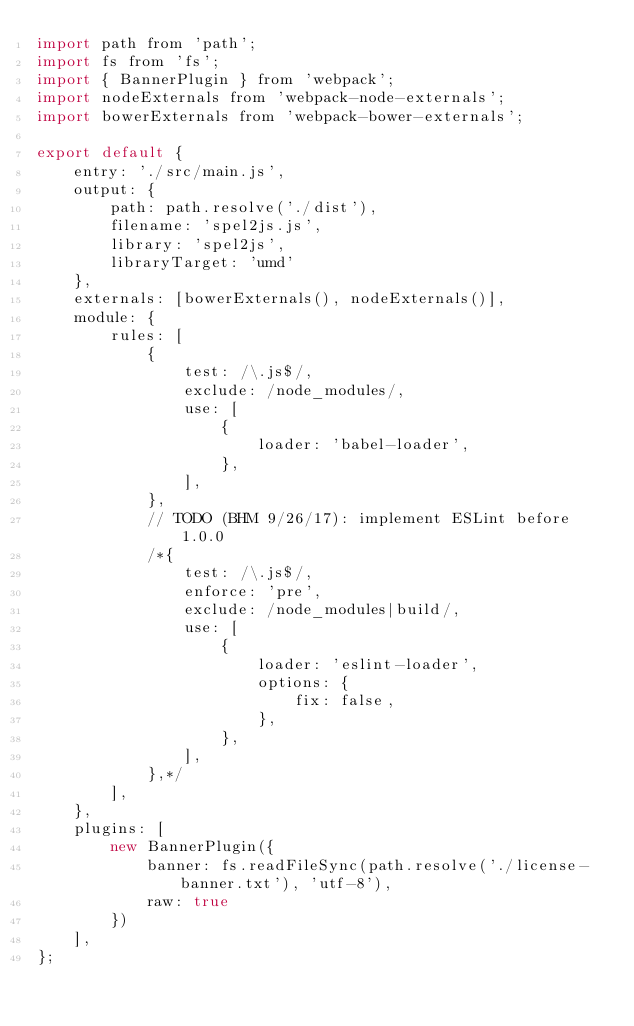<code> <loc_0><loc_0><loc_500><loc_500><_JavaScript_>import path from 'path';
import fs from 'fs';
import { BannerPlugin } from 'webpack';
import nodeExternals from 'webpack-node-externals';
import bowerExternals from 'webpack-bower-externals';

export default {
    entry: './src/main.js',
    output: {
        path: path.resolve('./dist'),
        filename: 'spel2js.js',
        library: 'spel2js',
        libraryTarget: 'umd'
    },
    externals: [bowerExternals(), nodeExternals()],
    module: {
        rules: [
            {
                test: /\.js$/,
                exclude: /node_modules/,
                use: [
                    {
                        loader: 'babel-loader',
                    },
                ],
            },
            // TODO (BHM 9/26/17): implement ESLint before 1.0.0
            /*{
                test: /\.js$/,
                enforce: 'pre',
                exclude: /node_modules|build/,
                use: [
                    {
                        loader: 'eslint-loader',
                        options: {
                            fix: false,
                        },
                    },
                ],
            },*/
        ],
    },
    plugins: [
        new BannerPlugin({
            banner: fs.readFileSync(path.resolve('./license-banner.txt'), 'utf-8'),
            raw: true
        })
    ],
};</code> 